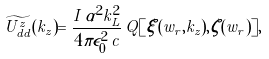Convert formula to latex. <formula><loc_0><loc_0><loc_500><loc_500>\widetilde { U ^ { z } _ { d d } } ( k _ { z } ) = \frac { I \, \alpha ^ { 2 } k _ { L } ^ { 2 } } { 4 \pi \epsilon _ { 0 } ^ { 2 } \, c } \, Q [ \xi ( w _ { r } , k _ { z } ) , \zeta ( w _ { r } ) ] ,</formula> 